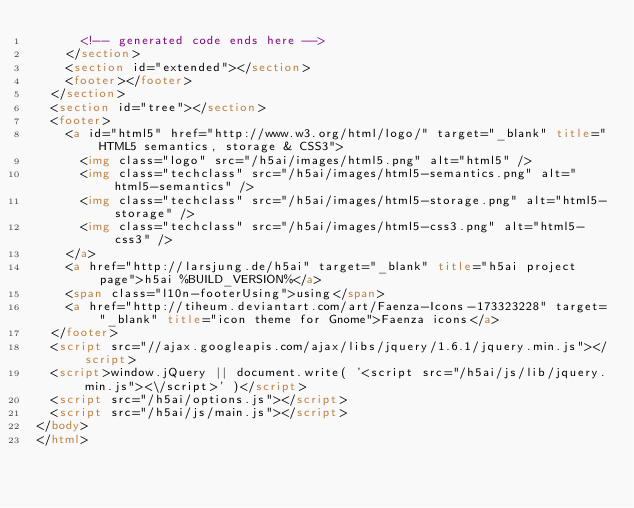<code> <loc_0><loc_0><loc_500><loc_500><_HTML_>			<!-- generated code ends here -->
		</section>
		<section id="extended"></section>
		<footer></footer>
	</section>
	<section id="tree"></section>
	<footer>
		<a id="html5" href="http://www.w3.org/html/logo/" target="_blank" title="HTML5 semantics, storage & CSS3">
			<img class="logo" src="/h5ai/images/html5.png" alt="html5" />
			<img class="techclass" src="/h5ai/images/html5-semantics.png" alt="html5-semantics" />
			<img class="techclass" src="/h5ai/images/html5-storage.png" alt="html5-storage" />
			<img class="techclass" src="/h5ai/images/html5-css3.png" alt="html5-css3" />
		</a>
		<a href="http://larsjung.de/h5ai" target="_blank" title="h5ai project page">h5ai %BUILD_VERSION%</a>
		<span class="l10n-footerUsing">using</span>
		<a href="http://tiheum.deviantart.com/art/Faenza-Icons-173323228" target="_blank" title="icon theme for Gnome">Faenza icons</a>
	</footer>
	<script src="//ajax.googleapis.com/ajax/libs/jquery/1.6.1/jquery.min.js"></script>
	<script>window.jQuery || document.write( '<script src="/h5ai/js/lib/jquery.min.js"><\/script>' )</script>
	<script src="/h5ai/options.js"></script>
	<script src="/h5ai/js/main.js"></script>
</body>
</html></code> 